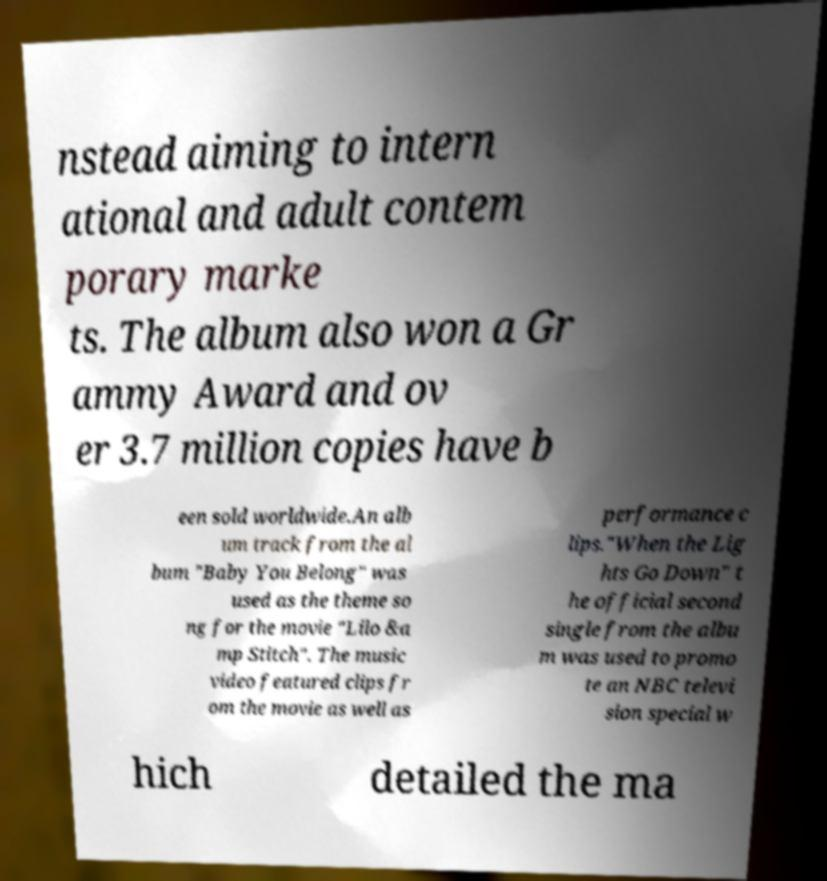Please identify and transcribe the text found in this image. nstead aiming to intern ational and adult contem porary marke ts. The album also won a Gr ammy Award and ov er 3.7 million copies have b een sold worldwide.An alb um track from the al bum "Baby You Belong" was used as the theme so ng for the movie "Lilo &a mp Stitch". The music video featured clips fr om the movie as well as performance c lips."When the Lig hts Go Down" t he official second single from the albu m was used to promo te an NBC televi sion special w hich detailed the ma 